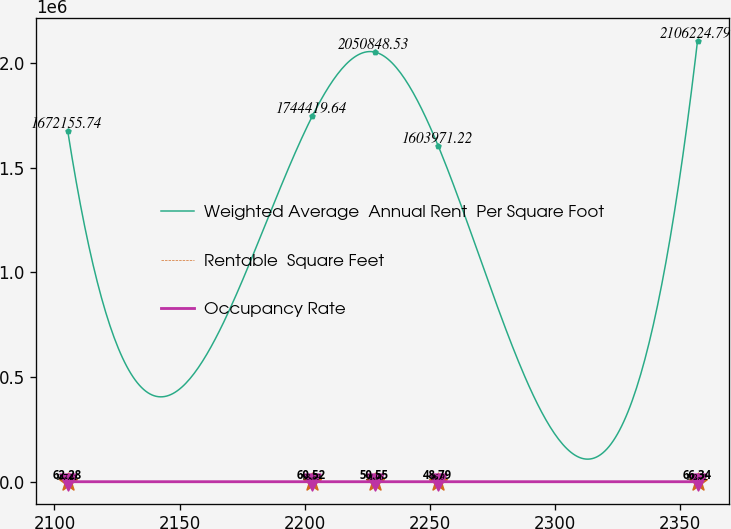Convert chart. <chart><loc_0><loc_0><loc_500><loc_500><line_chart><ecel><fcel>Weighted Average  Annual Rent  Per Square Foot<fcel>Rentable  Square Feet<fcel>Occupancy Rate<nl><fcel>2105.33<fcel>1.67216e+06<fcel>107.21<fcel>62.28<nl><fcel>2203.06<fcel>1.74442e+06<fcel>88.59<fcel>60.52<nl><fcel>2228.24<fcel>2.05085e+06<fcel>91.96<fcel>50.55<nl><fcel>2253.42<fcel>1.60397e+06<fcel>96.9<fcel>48.79<nl><fcel>2357.15<fcel>2.10622e+06<fcel>102.72<fcel>66.34<nl></chart> 